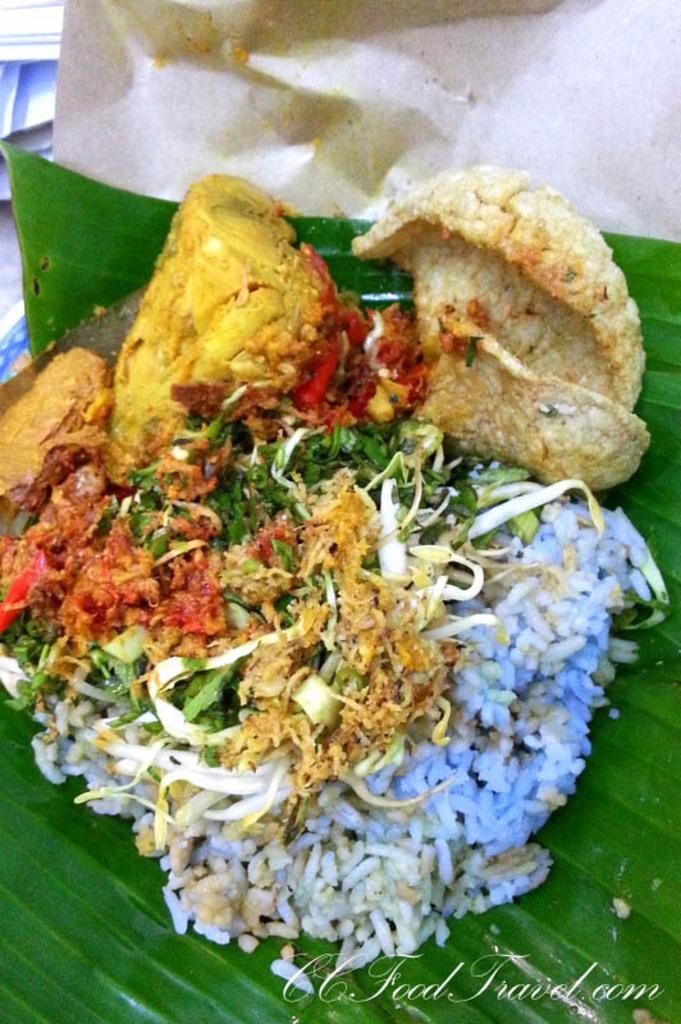In one or two sentences, can you explain what this image depicts? In this image there is a banana leaf on which there is rice,green leaves and some food stuff. Banana leaf is on paper. 